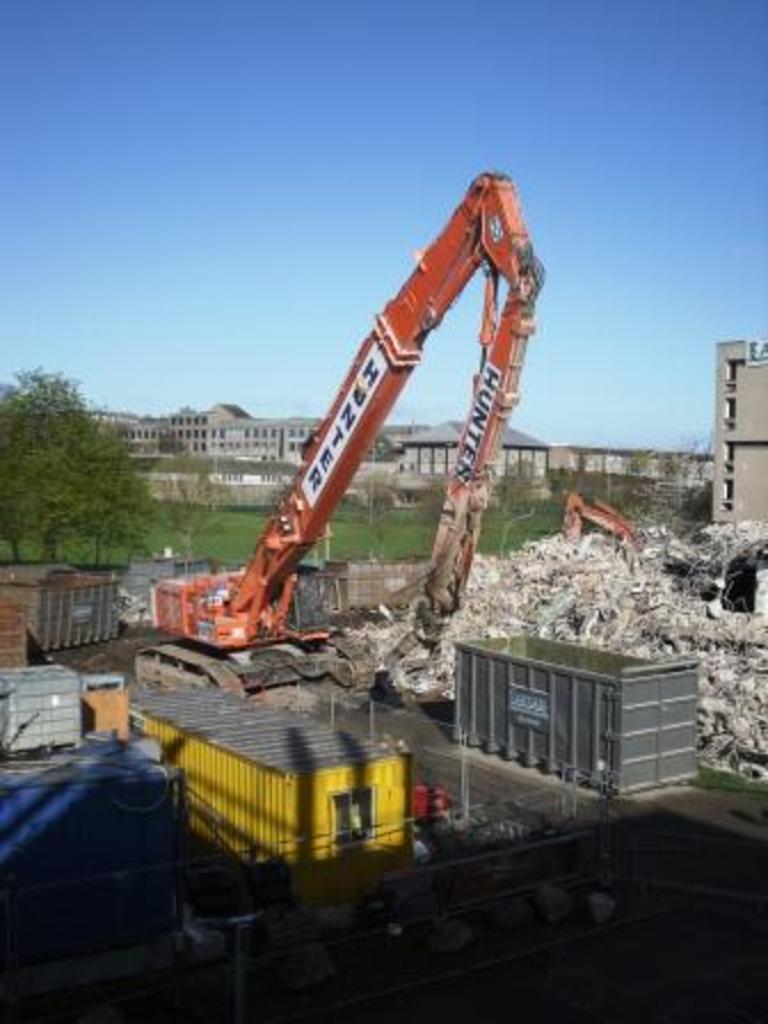Can you describe this image briefly? In the picture we can see a drilling equipment vehicle and near to it we can see some boxes and beside it we can see scrap and in the background we can see a part of tree and grass surface and behind it we can see a building and behind it we can see the sky. 